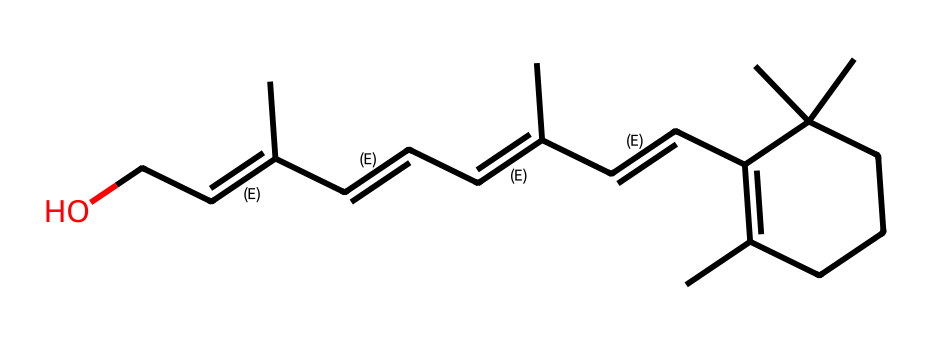What is the molecular formula of retinol? To determine the molecular formula, count the number of each type of atom in the SMILES representation. The structure depicts 20 carbons, 30 hydrogens, and 1 oxygen, leading to the molecular formula C20H30O.
Answer: C20H30O How many double bonds are present in this chemical structure? By examining the SMILES notation, we notice 6 double bonds represented by the "=" signs present in the structure. Therefore, there are 6 double bonds in total.
Answer: 6 What functional group is present in retinol? The presence of -OH (hydroxyl) in the structure indicates that retinol contains an alcohol functional group, which is characteristic of its molecular structure.
Answer: alcohol What property of retinol relates to its photosensitivity? The alternating double and single bonds in the structure create a conjugated system, which is key to its ability to react to light. This configuration allows for resonance and makes it sensitive to UV light.
Answer: conjugation What is the significance of the long carbon chain in the structure? The long hydrocarbon chain in retinol contributes to its stability as a molecule and allows for lipophilic interactions in biological systems, thus reinforcing its function in cellular processes.
Answer: stability Which part of the retinol structure is responsible for its photoreactive behavior? The conjugated double bond system, specifically the sequence of alternating double and single bonds, enables absorption of light, making this part of the molecule critical for its photoreactivity.
Answer: double bond system 